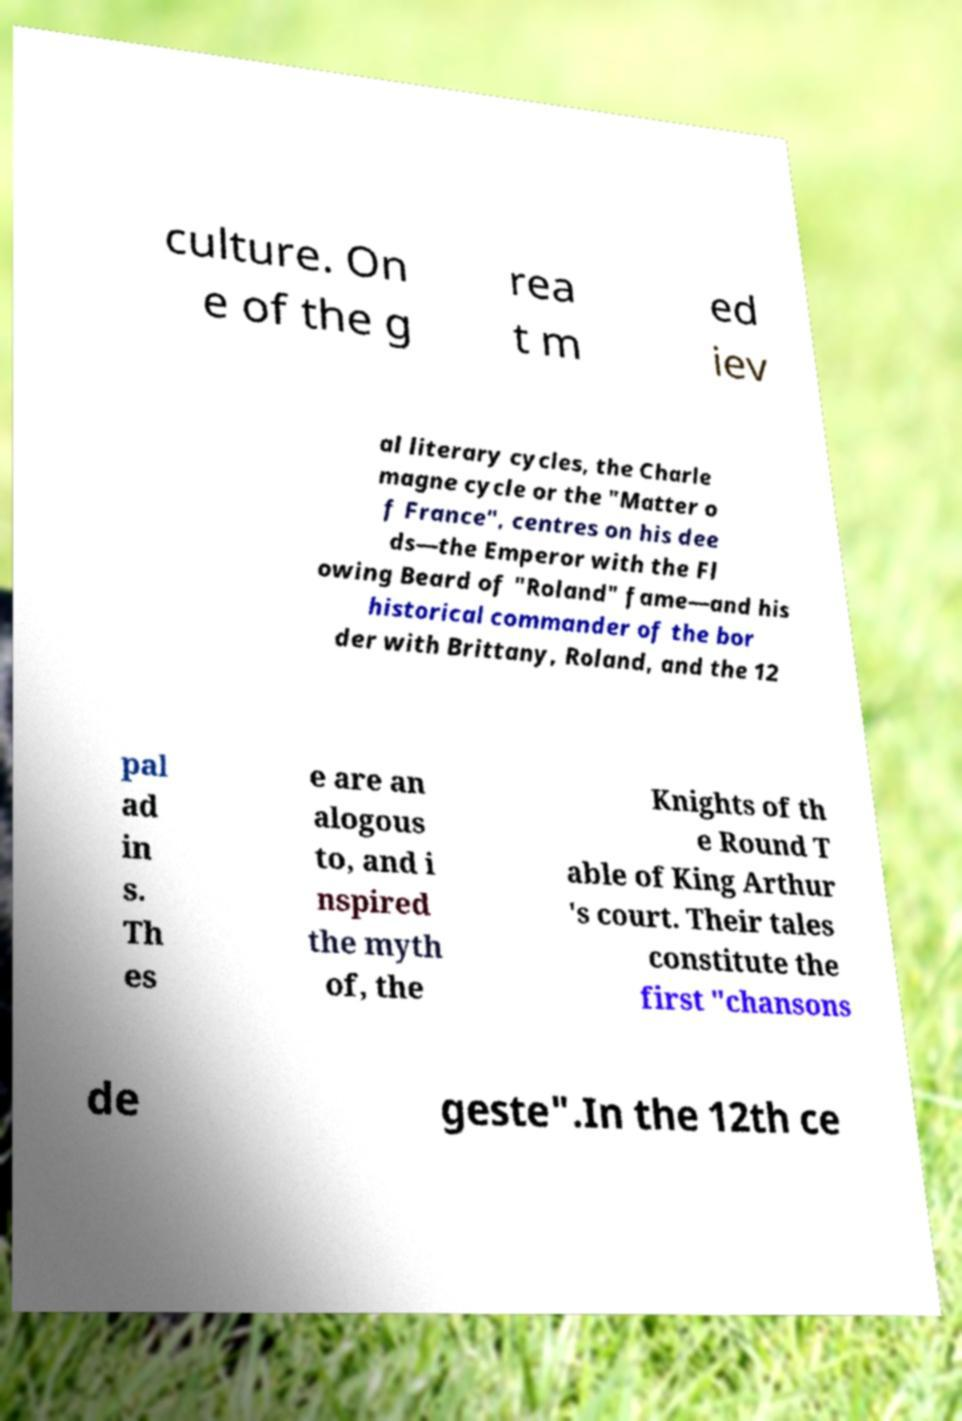Can you read and provide the text displayed in the image?This photo seems to have some interesting text. Can you extract and type it out for me? culture. On e of the g rea t m ed iev al literary cycles, the Charle magne cycle or the "Matter o f France", centres on his dee ds—the Emperor with the Fl owing Beard of "Roland" fame—and his historical commander of the bor der with Brittany, Roland, and the 12 pal ad in s. Th es e are an alogous to, and i nspired the myth of, the Knights of th e Round T able of King Arthur 's court. Their tales constitute the first "chansons de geste".In the 12th ce 